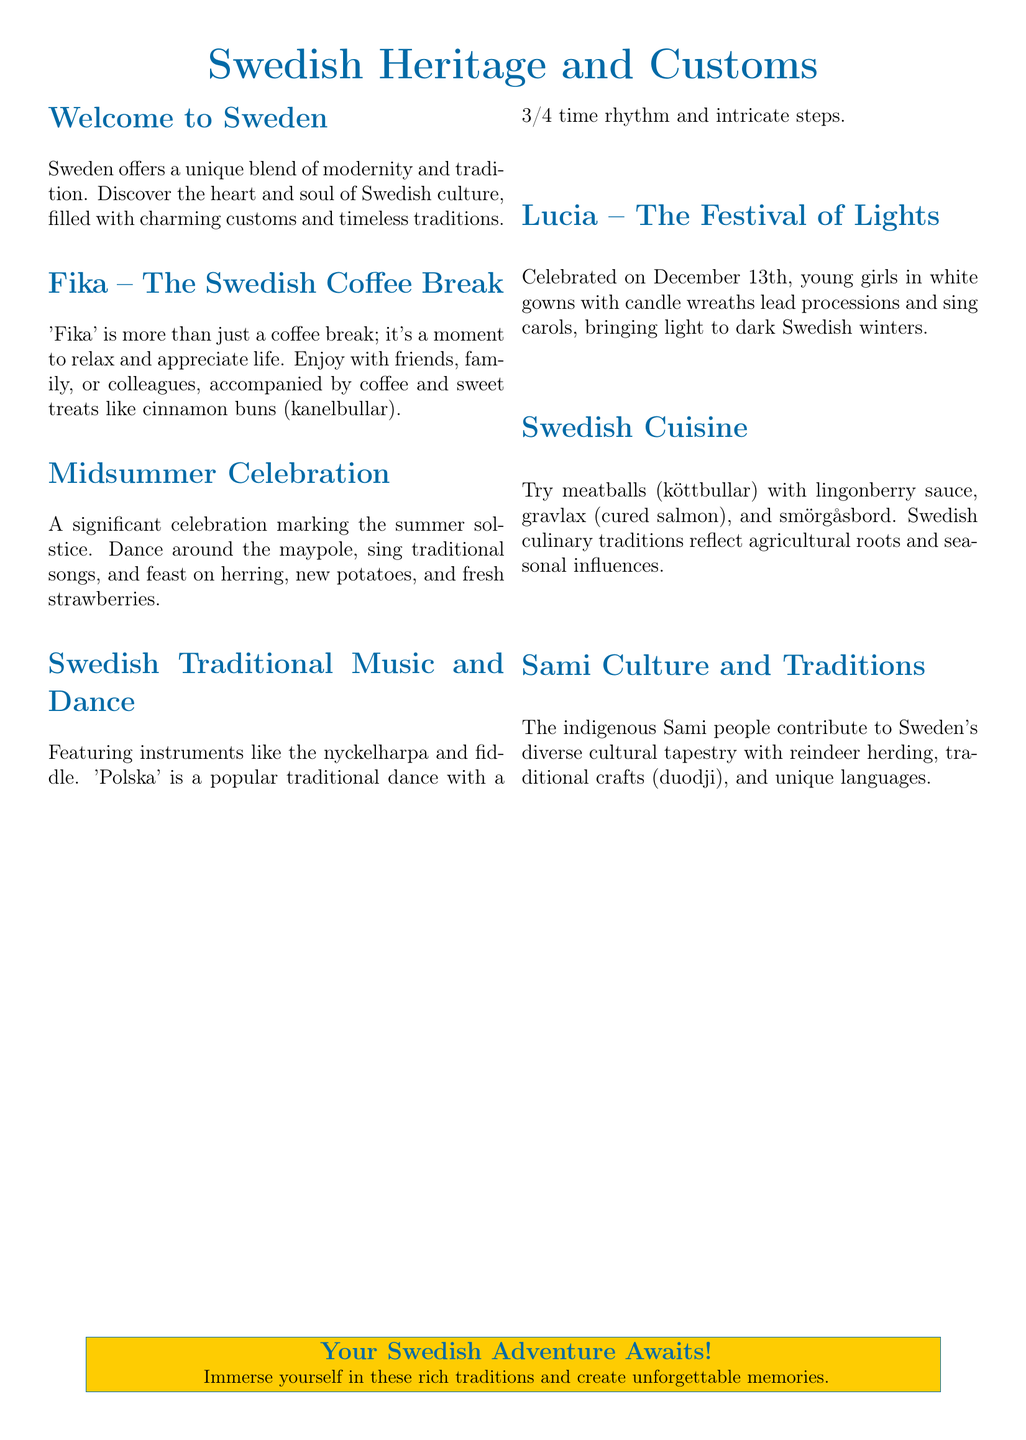What is 'Fika'? 'Fika' is defined in the document as a moment to relax and appreciate life, enjoying coffee and sweet treats.
Answer: A coffee break What is celebrated on December 13th? The document states that Lucia is celebrated on December 13th with young girls in white gowns leading processions.
Answer: Lucia Which instrument is mentioned in Swedish traditional music? The nyckelharpa is specifically mentioned as an instrument in the document.
Answer: Nyckelharpa What food is commonly eaten during Midsummer celebrations? The document lists herring, new potatoes, and fresh strawberries as food for this celebration.
Answer: Herring What dance has a 3/4 time rhythm? The 'Polska' is identified in the document as a popular dance with a 3/4 time rhythm.
Answer: Polska How do the Sami people contribute to Swedish culture? The document indicates that the Sami contribute with reindeer herding and traditional crafts.
Answer: Reindeer herding What is included in a traditional Swedish meal? The document features meatballs with lingonberry sauce, gravlax, and smörgåsbord as part of Swedish cuisine.
Answer: Meatballs Which season is Midsummer associated with? The document explicitly states that Midsummer marks the summer solstice.
Answer: Summer How does the document conclude? The document concludes with a message inviting readers to immerse themselves in Swedish traditions.
Answer: Your Swedish Adventure Awaits! 